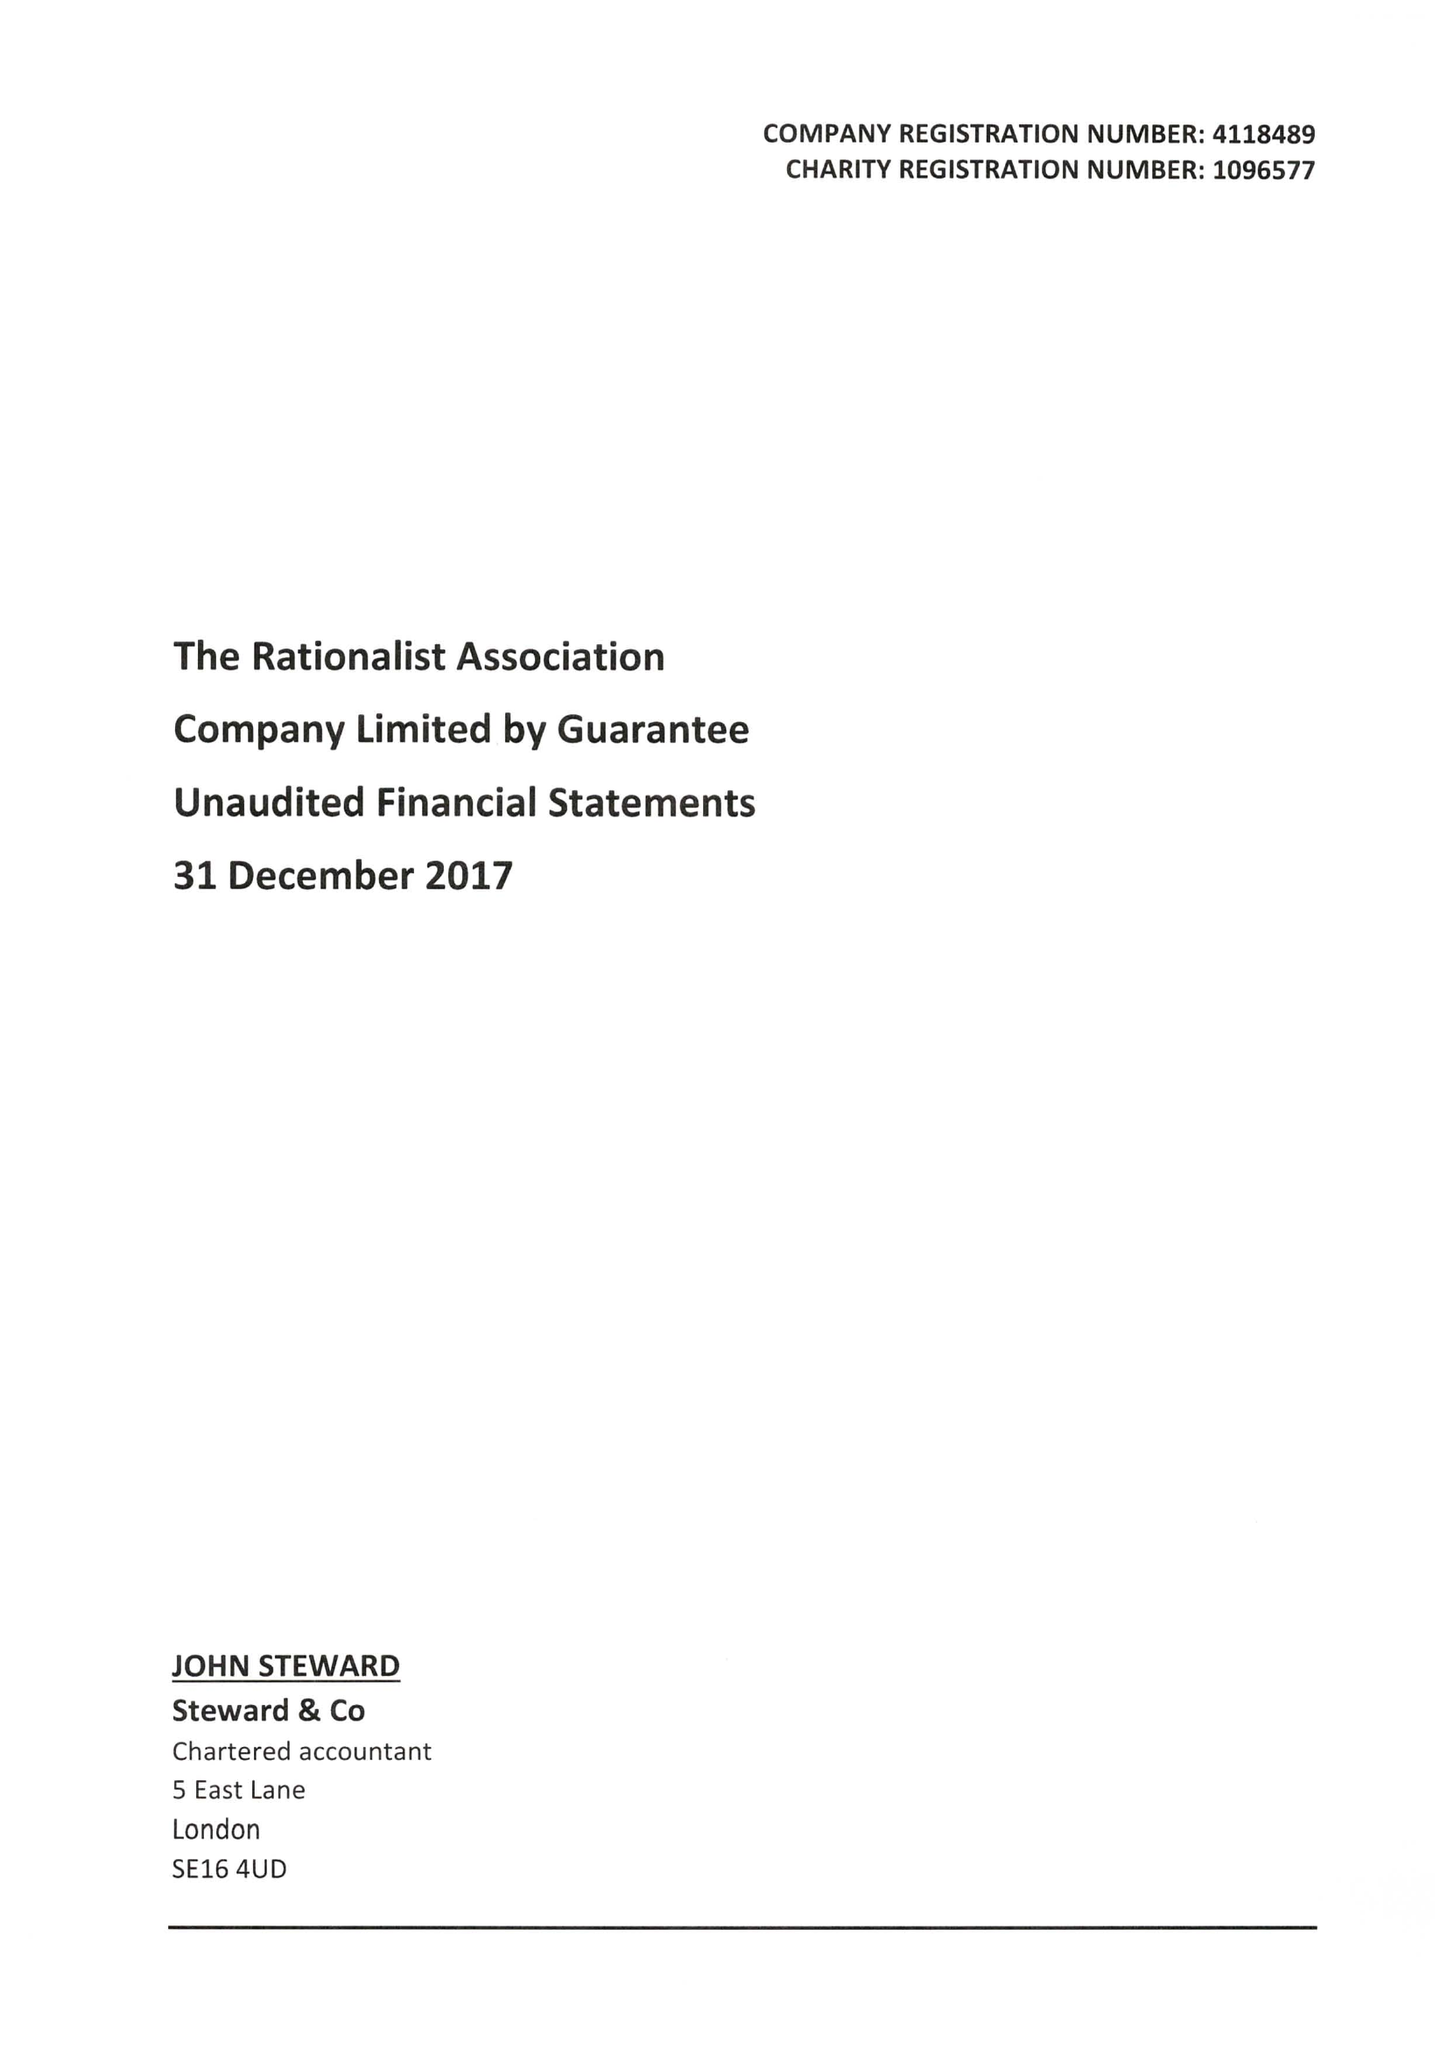What is the value for the report_date?
Answer the question using a single word or phrase. 2017-12-31 